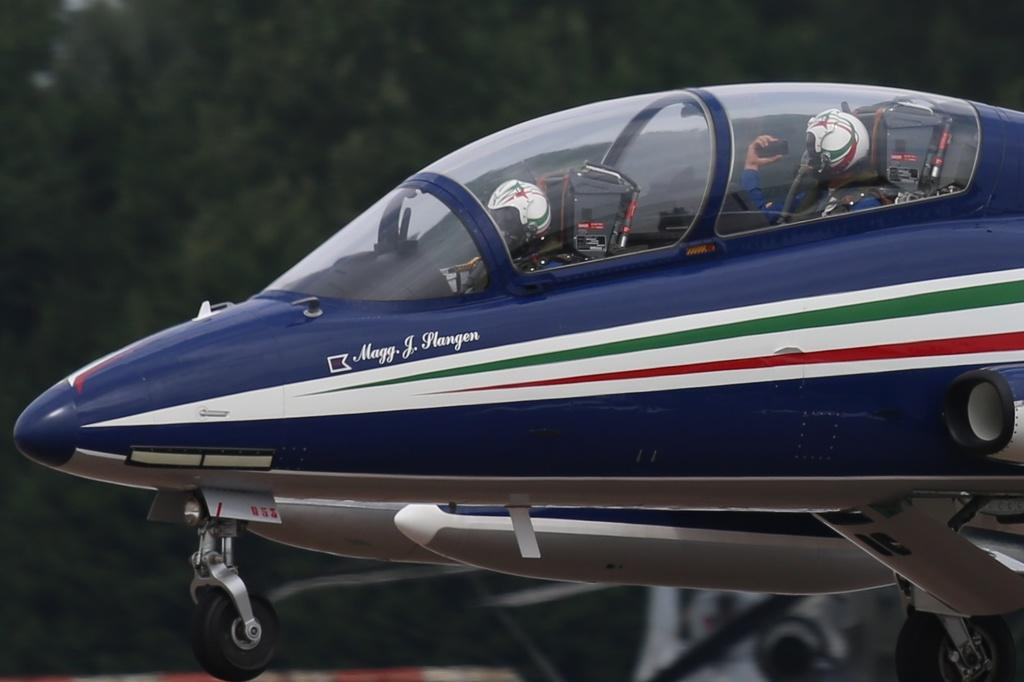How many people are in the image? There are two persons in the image. What are the persons doing in the image? The persons are sitting in an aircraft. What color is the aircraft? The aircraft is violet in color. Can you describe the background of the image? The background of the image is blurred. What type of lumber can be seen in the image? There is no lumber present in the image; it features two persons sitting in a violet aircraft with a blurred background. 